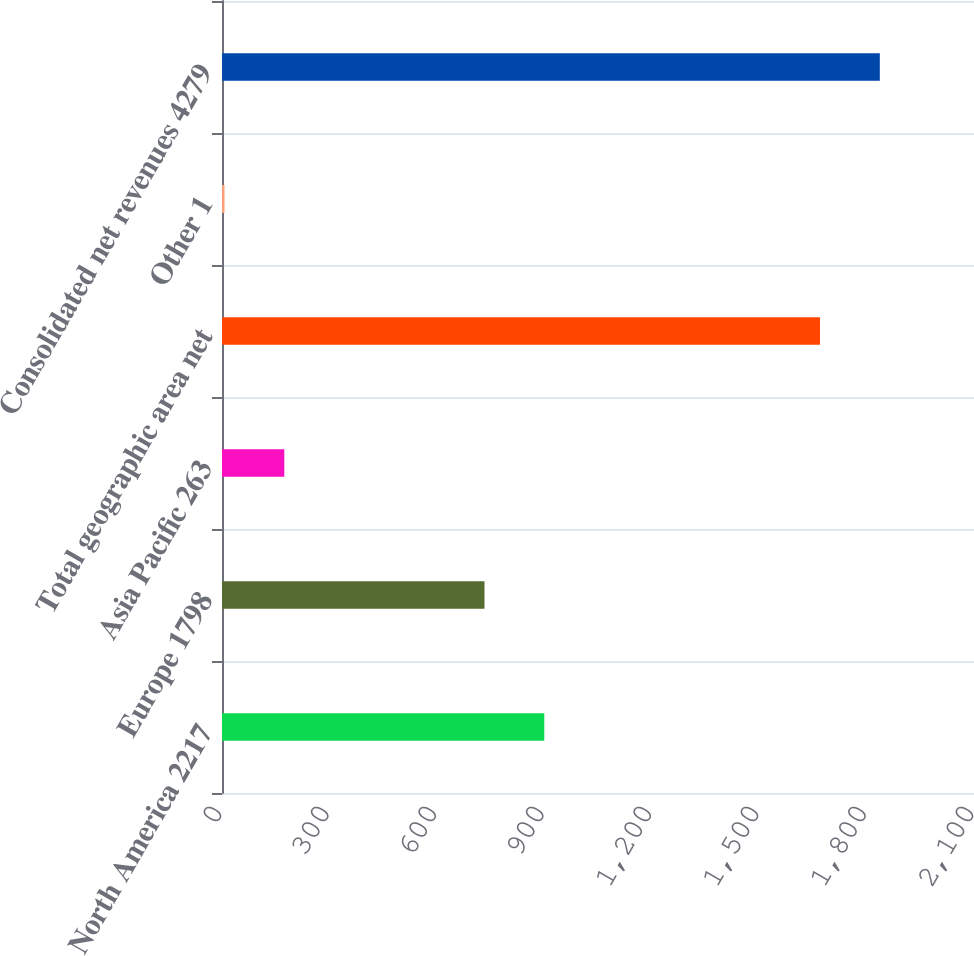<chart> <loc_0><loc_0><loc_500><loc_500><bar_chart><fcel>North America 2217<fcel>Europe 1798<fcel>Asia Pacific 263<fcel>Total geographic area net<fcel>Other 1<fcel>Consolidated net revenues 4279<nl><fcel>900<fcel>733<fcel>174<fcel>1670<fcel>7<fcel>1837<nl></chart> 